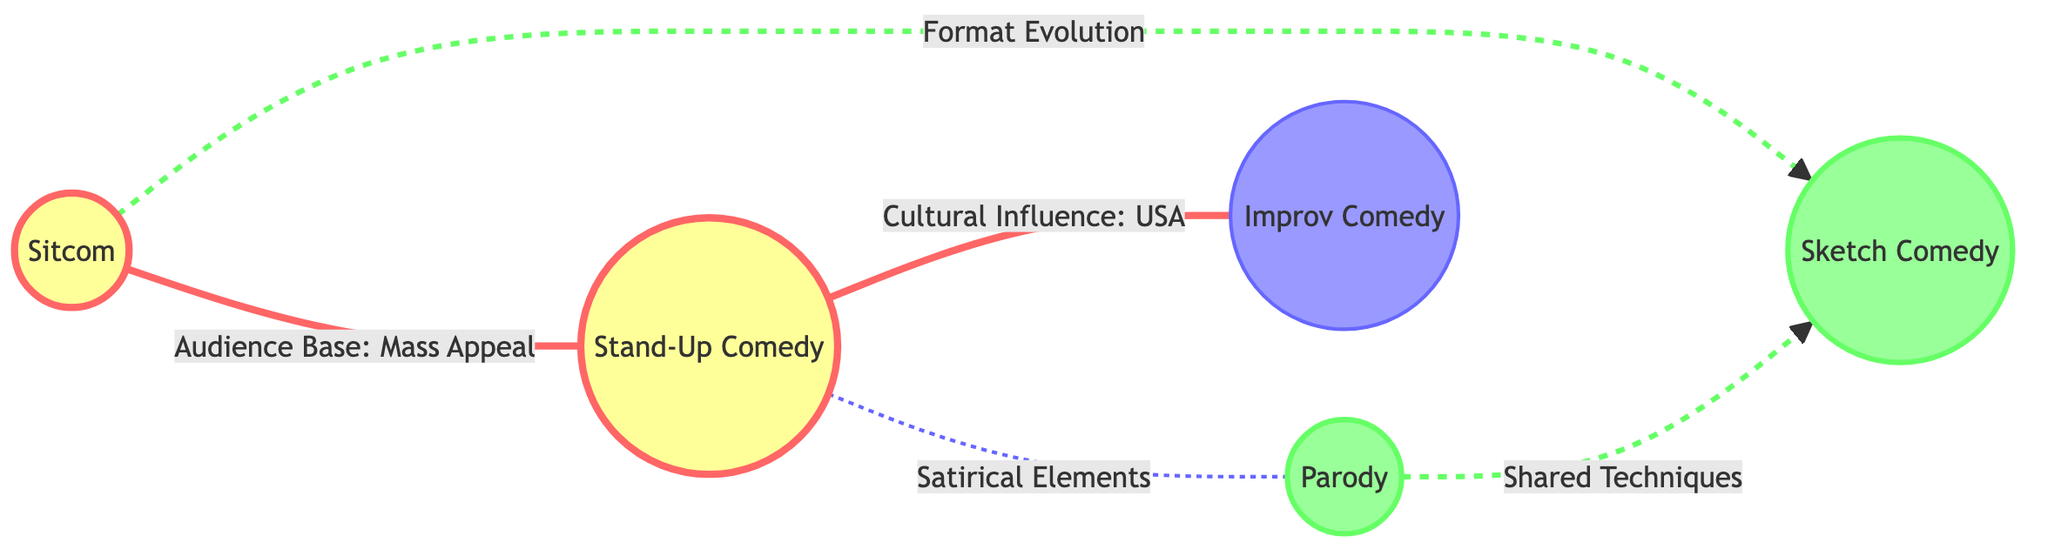What is the strongest cultural influence present in the diagram? The strongest cultural influence depicted in the diagram is related to Stand-Up Comedy, which connects to Improv Comedy as "Cultural Influence: USA." This indicates a direct influence from Stand-Up to Improv, highlighting the cultural significance of Stand-Up.
Answer: Cultural Influence: USA How many main comedy genres are represented in the diagram? The diagram includes five main comedy genres: Stand-Up Comedy, Sitcom, Improv Comedy, Sketch Comedy, and Parody. By counting the distinct nodes, we ascertain there are a total of five genres represented.
Answer: 5 What type of relationship exists between Sitcom and Sketch Comedy? The relationship between Sitcom and Sketch Comedy is depicted as a dashed line with an annotation "Format Evolution," indicating that these two genres are related through their evolution in format. The dash signifies that it is a weaker or more indirect relationship compared to solid lines.
Answer: Format Evolution Which comedy genre has the weakest influence according to the diagram? The weakest influence is attributed to Improv Comedy, as indicated by the style applied to this node, which is filled with a design representing weak influence. This suggests that it is less foundational compared to the others.
Answer: Improv Comedy What is the relationship between Stand-Up Comedy and Parody? Stand-Up Comedy and Parody have a relationship depicted by a dashed line labeled "Satirical Elements," which suggests that while there is a connection, it may not be as strong as the connections represented by solid lines.
Answer: Satirical Elements Which two genres share common techniques according to the diagram? The genres that share common techniques are Parody and Sketch Comedy, as indicated by the dashed line labeled "Shared Techniques," which denotes a moderate relationship between them.
Answer: Shared Techniques What do the dashed lines in the diagram signify? The dashed lines represent relationships that are weaker or more indirect connections than those signified by solid lines. Each dashed line includes a description of the nature of the relationship, illustrating its comparative strength.
Answer: Weaker relationships How are the audience bases of Sitcom and Stand-Up Comedy related? Sitcom and Stand-Up Comedy have a direct relationship shown with a solid line stating "Audience Base: Mass Appeal," which implies that both genres target a broad audience segment, indicating a strong connection based on their appeal.
Answer: Audience Base: Mass Appeal 